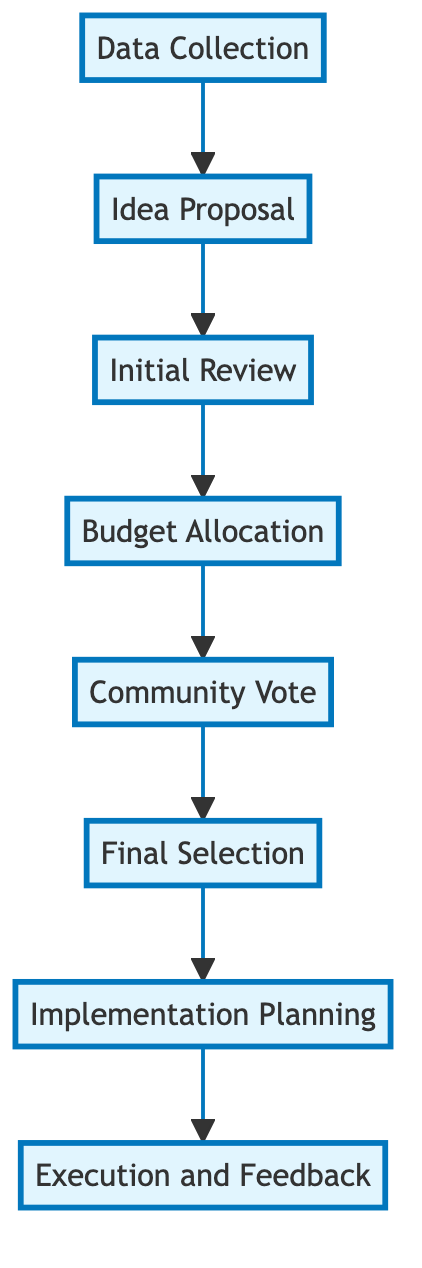What is the first step in the diagram? The diagram indicates "Data Collection" as the first step in the implementation process, making it the starting point of the flow.
Answer: Data Collection How many main steps are involved in the participatory budgeting process? Counting all the nodes listed in the diagram, there are eight main steps involved from start to finish.
Answer: 8 Which step directly follows the "Community Vote"? Following "Community Vote," the next step in the flow is "Final Selection," which indicates the proposals that received the highest votes will be considered.
Answer: Final Selection What role does the finance team play in the process? The finance team is responsible for "Budget Allocation," where they calculate and allocate funds for each approved proposal based on the initial review.
Answer: Budget Allocation What is the outcome of the "Execution and Feedback" step? The outcome of "Execution and Feedback" is that selected projects are executed, and feedback is gathered to improve future cycles, indicating a continuous improvement process.
Answer: Continuous feedback Which step involves a committee review? The step that involves a committee review to assess feasibility and impact of proposals is the "Initial Review" step in the process.
Answer: Initial Review How are the projects chosen for implementation? Projects are chosen for implementation based on the voting results collected during the "Community Vote," where the highest votes lead to the "Final Selection."
Answer: Highest votes Describe the main purpose of "Implementation Planning." The main purpose of "Implementation Planning" is to create detailed plans and timelines for the selected projects, ensuring organized execution and follow-up checks on progress.
Answer: Create plans and timelines 